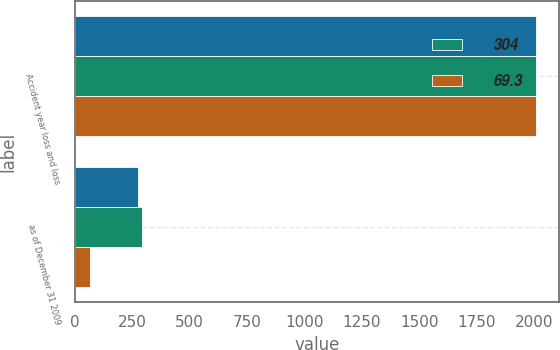<chart> <loc_0><loc_0><loc_500><loc_500><stacked_bar_chart><ecel><fcel>Accident year loss and loss<fcel>as of December 31 2009<nl><fcel>nan<fcel>2009<fcel>276<nl><fcel>304<fcel>2007<fcel>293<nl><fcel>69.3<fcel>2007<fcel>66.7<nl></chart> 